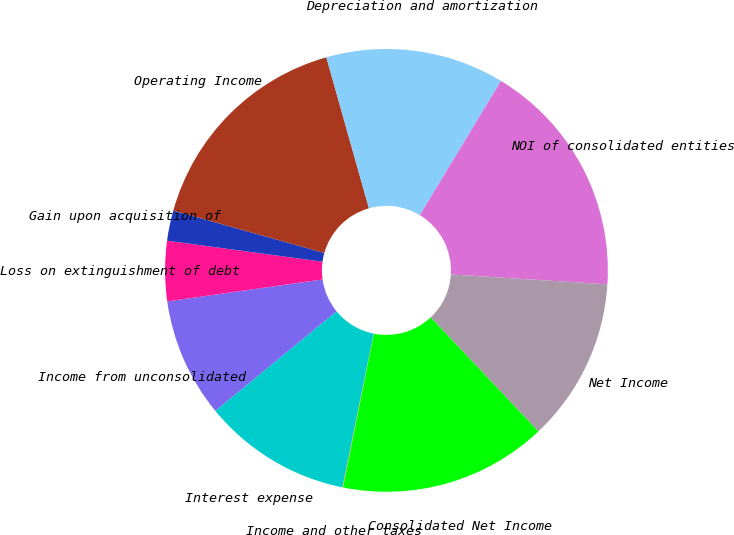<chart> <loc_0><loc_0><loc_500><loc_500><pie_chart><fcel>Consolidated Net Income<fcel>Income and other taxes<fcel>Interest expense<fcel>Income from unconsolidated<fcel>Loss on extinguishment of debt<fcel>Gain upon acquisition of<fcel>Operating Income<fcel>Depreciation and amortization<fcel>NOI of consolidated entities<fcel>Net Income<nl><fcel>15.19%<fcel>0.05%<fcel>10.87%<fcel>8.7%<fcel>4.38%<fcel>2.21%<fcel>16.27%<fcel>13.03%<fcel>17.35%<fcel>11.95%<nl></chart> 